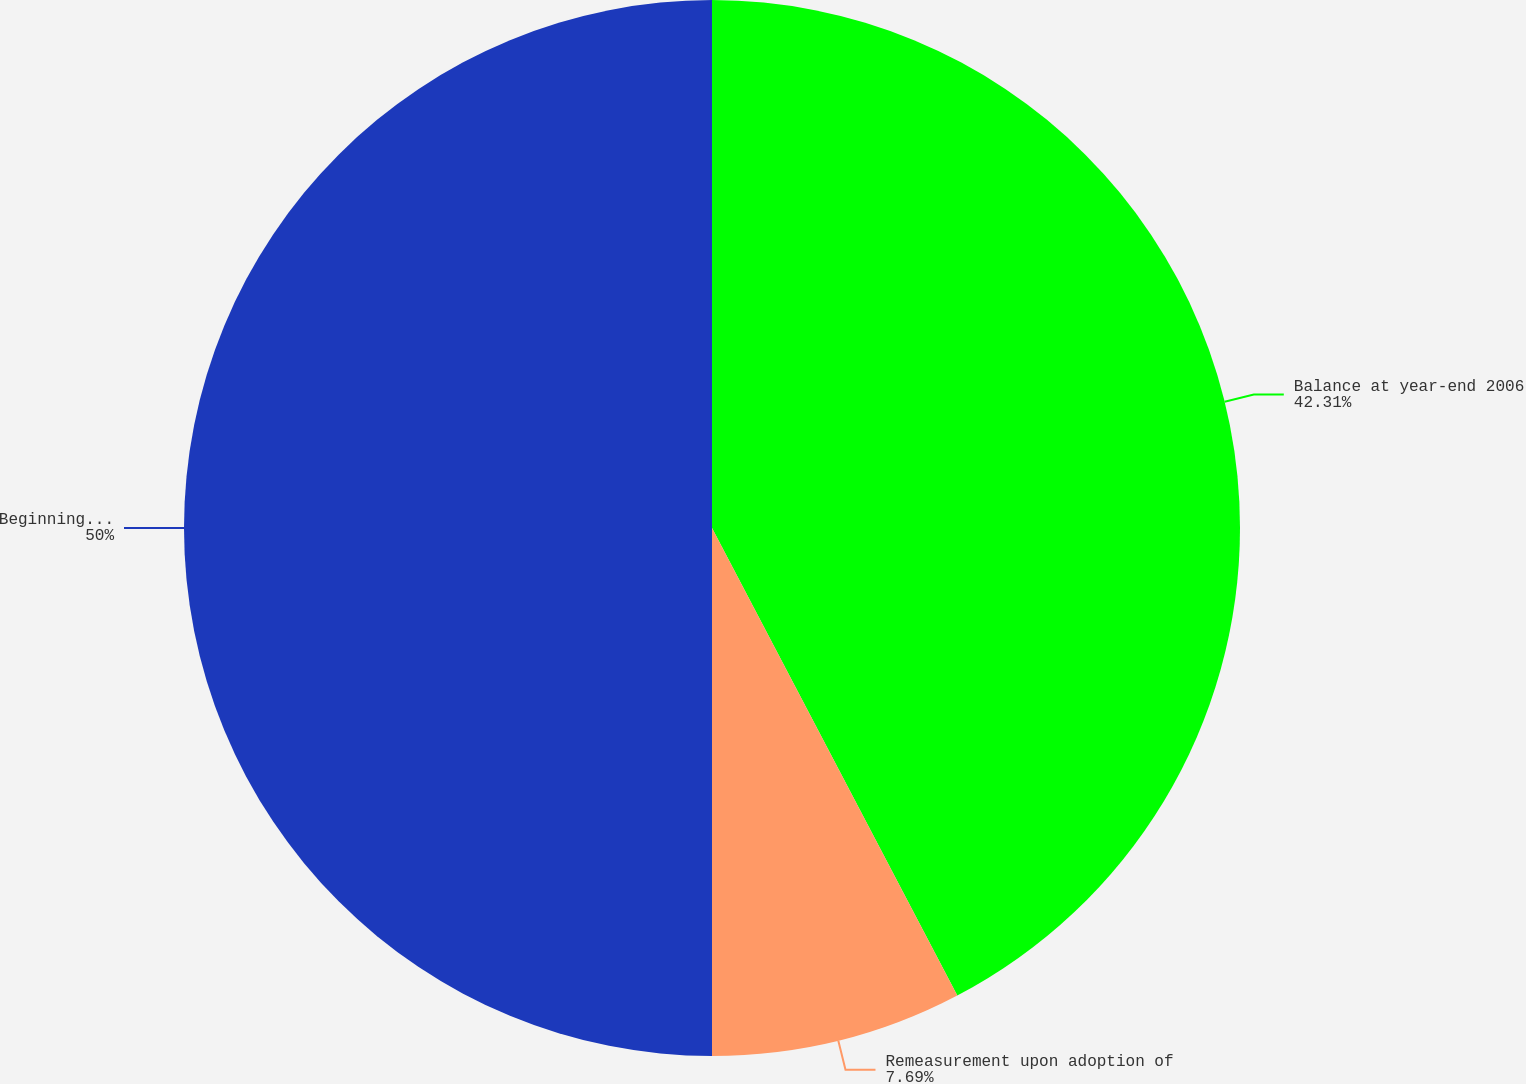Convert chart. <chart><loc_0><loc_0><loc_500><loc_500><pie_chart><fcel>Balance at year-end 2006<fcel>Remeasurement upon adoption of<fcel>Beginning balance at December<nl><fcel>42.31%<fcel>7.69%<fcel>50.0%<nl></chart> 